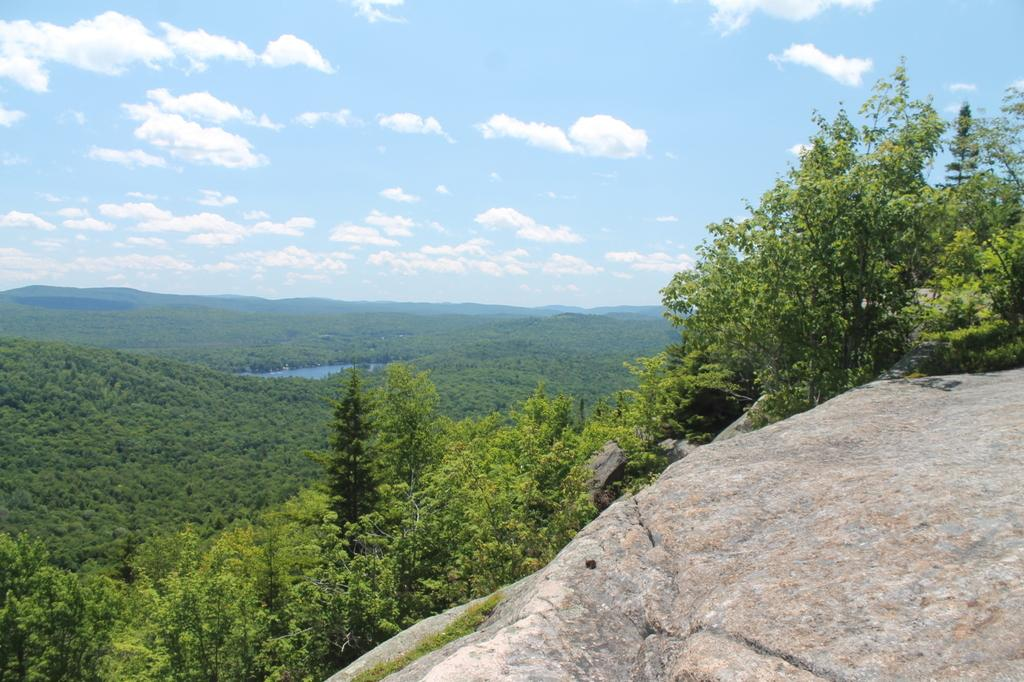What is located at the front of the image? There is a stone in the front of the image. What can be seen in the center of the image? There are trees in the center of the image. What natural element is visible in the image? Water is visible in the image. How would you describe the sky in the image? The sky is cloudy. How many beds can be seen at the edge of the water in the image? There are no beds present in the image, and the image does not show an edge of the water. 